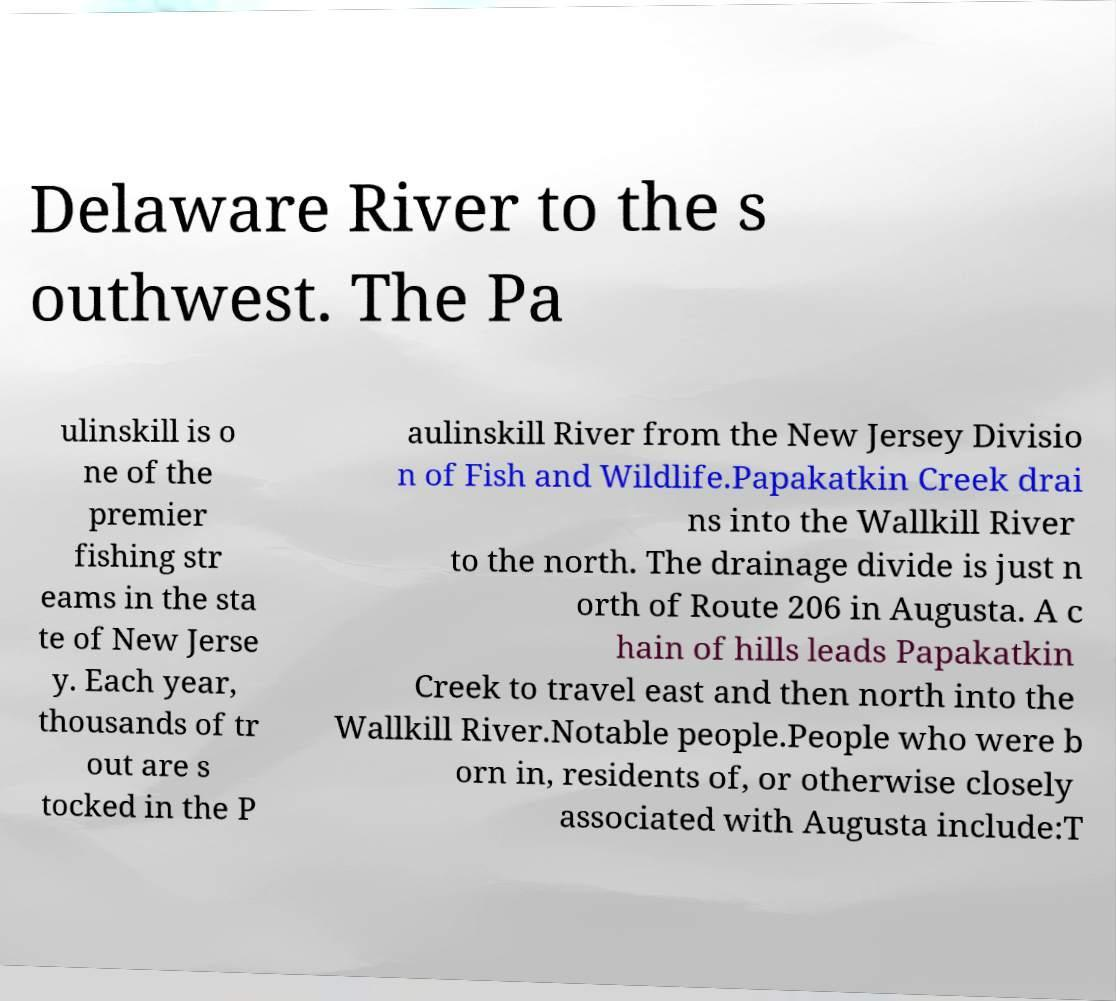I need the written content from this picture converted into text. Can you do that? Delaware River to the s outhwest. The Pa ulinskill is o ne of the premier fishing str eams in the sta te of New Jerse y. Each year, thousands of tr out are s tocked in the P aulinskill River from the New Jersey Divisio n of Fish and Wildlife.Papakatkin Creek drai ns into the Wallkill River to the north. The drainage divide is just n orth of Route 206 in Augusta. A c hain of hills leads Papakatkin Creek to travel east and then north into the Wallkill River.Notable people.People who were b orn in, residents of, or otherwise closely associated with Augusta include:T 